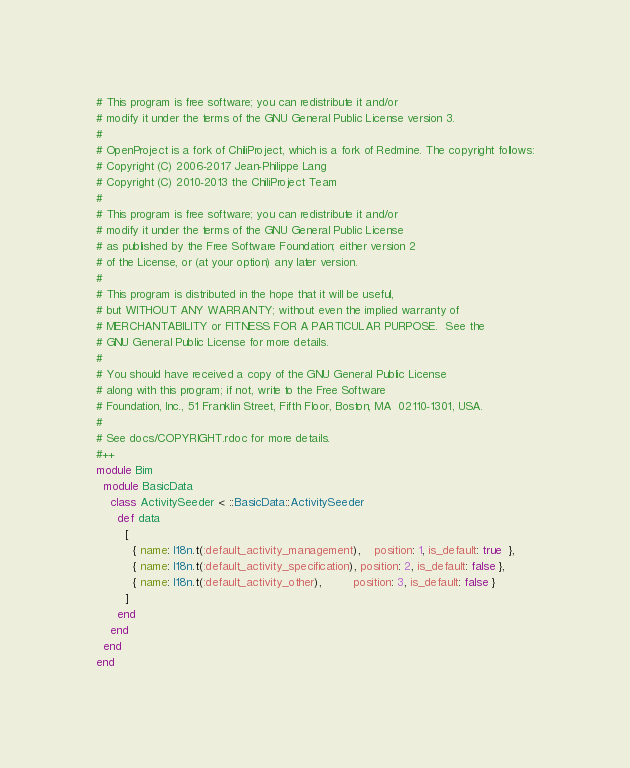<code> <loc_0><loc_0><loc_500><loc_500><_Ruby_># This program is free software; you can redistribute it and/or
# modify it under the terms of the GNU General Public License version 3.
#
# OpenProject is a fork of ChiliProject, which is a fork of Redmine. The copyright follows:
# Copyright (C) 2006-2017 Jean-Philippe Lang
# Copyright (C) 2010-2013 the ChiliProject Team
#
# This program is free software; you can redistribute it and/or
# modify it under the terms of the GNU General Public License
# as published by the Free Software Foundation; either version 2
# of the License, or (at your option) any later version.
#
# This program is distributed in the hope that it will be useful,
# but WITHOUT ANY WARRANTY; without even the implied warranty of
# MERCHANTABILITY or FITNESS FOR A PARTICULAR PURPOSE.  See the
# GNU General Public License for more details.
#
# You should have received a copy of the GNU General Public License
# along with this program; if not, write to the Free Software
# Foundation, Inc., 51 Franklin Street, Fifth Floor, Boston, MA  02110-1301, USA.
#
# See docs/COPYRIGHT.rdoc for more details.
#++
module Bim
  module BasicData
    class ActivitySeeder < ::BasicData::ActivitySeeder
      def data
        [
          { name: I18n.t(:default_activity_management),    position: 1, is_default: true  },
          { name: I18n.t(:default_activity_specification), position: 2, is_default: false },
          { name: I18n.t(:default_activity_other),         position: 3, is_default: false }
        ]
      end
    end
  end
end
</code> 